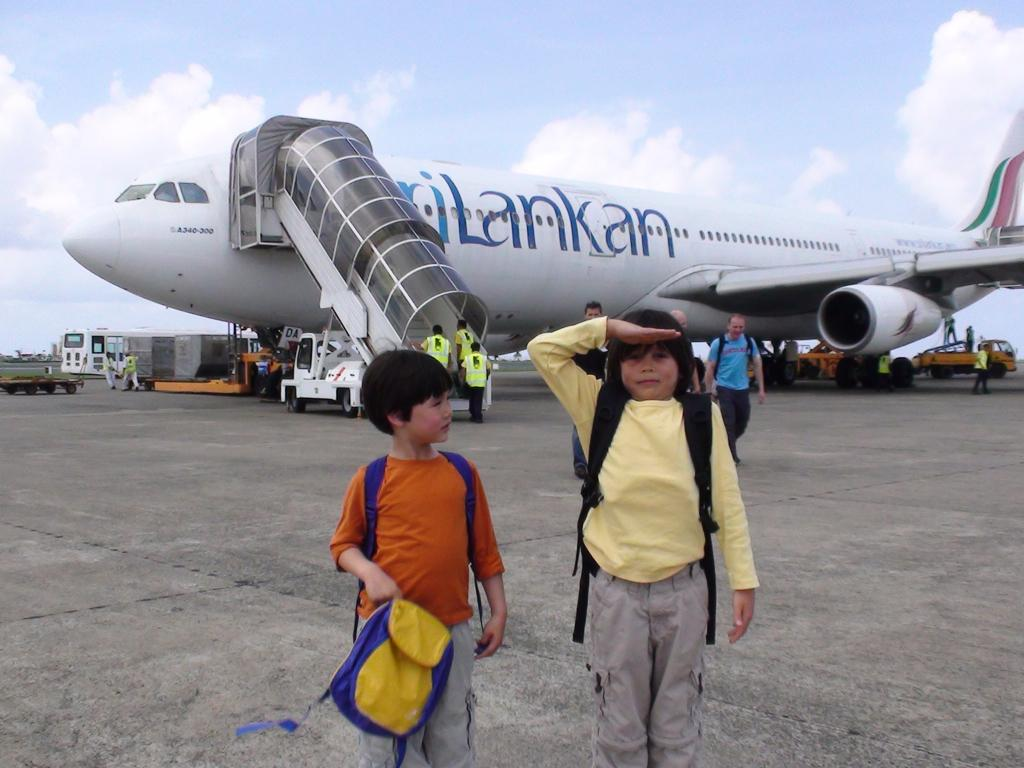What are the people in the image doing? Some people are standing, and others are walking in the image. What else can be seen in the image besides people? There are vehicles and an airplane with passenger steps on the runway in the image. What is visible in the background of the image? The sky is visible in the background of the image. Where is the zoo located in the image? There is no zoo present in the image. What type of knee injury can be seen on the person walking in the image? There is no indication of any knee injury on the person walking in the image. 